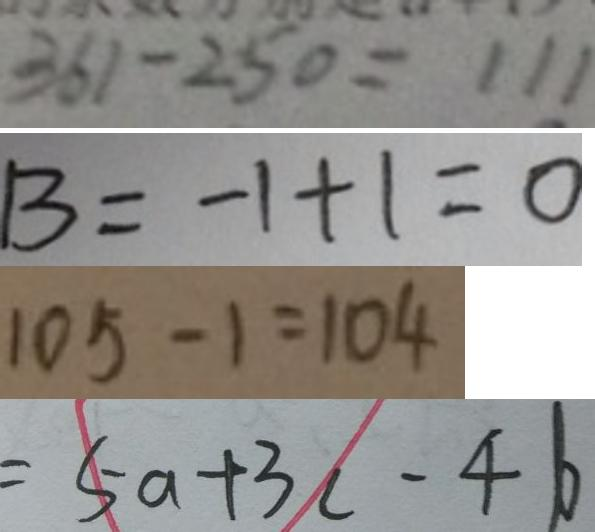Convert formula to latex. <formula><loc_0><loc_0><loc_500><loc_500>3 6 1 - 2 5 0 = 1 1 1 
 B = - 1 + 1 = 0 
 1 0 5 - 1 = 1 0 4 
 = 5 a + 3 c - 4 b</formula> 